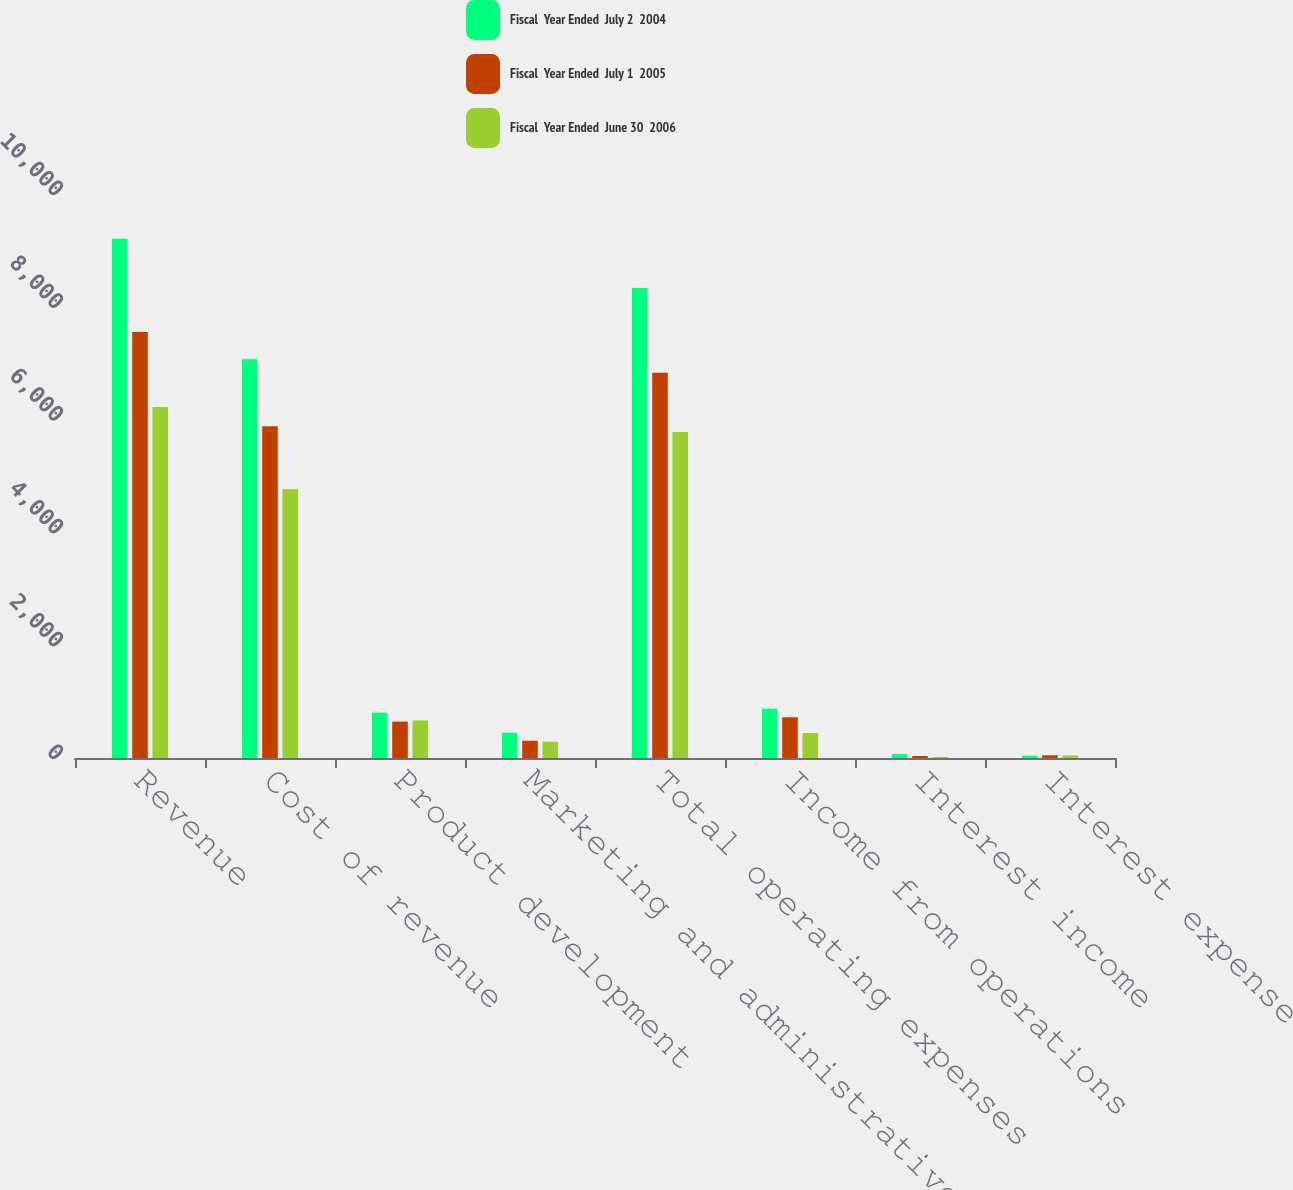<chart> <loc_0><loc_0><loc_500><loc_500><stacked_bar_chart><ecel><fcel>Revenue<fcel>Cost of revenue<fcel>Product development<fcel>Marketing and administrative<fcel>Total operating expenses<fcel>Income from operations<fcel>Interest income<fcel>Interest expense<nl><fcel>Fiscal  Year Ended  July 2  2004<fcel>9206<fcel>7069<fcel>805<fcel>447<fcel>8332<fcel>874<fcel>69<fcel>41<nl><fcel>Fiscal  Year Ended  July 1  2005<fcel>7553<fcel>5880<fcel>645<fcel>306<fcel>6831<fcel>722<fcel>36<fcel>48<nl><fcel>Fiscal  Year Ended  June 30  2006<fcel>6224<fcel>4765<fcel>666<fcel>290<fcel>5780<fcel>444<fcel>17<fcel>45<nl></chart> 